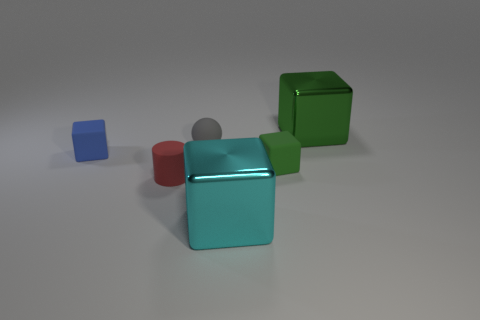Subtract all blue blocks. How many blocks are left? 3 Subtract all gray spheres. How many green blocks are left? 2 Subtract all green cubes. How many cubes are left? 2 Subtract 1 cubes. How many cubes are left? 3 Add 2 tiny blue matte blocks. How many objects exist? 8 Subtract all cylinders. How many objects are left? 5 Add 3 cyan metallic blocks. How many cyan metallic blocks are left? 4 Add 3 tiny green blocks. How many tiny green blocks exist? 4 Subtract 0 purple cubes. How many objects are left? 6 Subtract all green blocks. Subtract all blue spheres. How many blocks are left? 2 